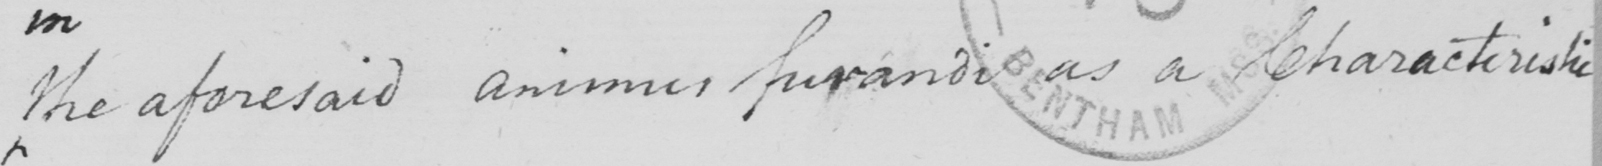Can you tell me what this handwritten text says? the aforesaid animus furandi as a characteristic 